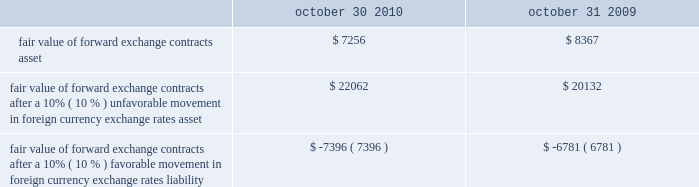The table illustrates the effect that a 10% ( 10 % ) unfavorable or favorable movement in foreign currency exchange rates , relative to the u.s .
Dollar , would have on the fair value of our forward exchange contracts as of october 30 , 2010 and october 31 , 2009: .
Fair value of forward exchange contracts after a 10% ( 10 % ) unfavorable movement in foreign currency exchange rates asset .
$ 22062 $ 20132 fair value of forward exchange contracts after a 10% ( 10 % ) favorable movement in foreign currency exchange rates liability .
$ ( 7396 ) $ ( 6781 ) the calculation assumes that each exchange rate would change in the same direction relative to the u.s .
Dollar .
In addition to the direct effects of changes in exchange rates , such changes typically affect the volume of sales or the foreign currency sales price as competitors 2019 products become more or less attractive .
Our sensitivity analysis of the effects of changes in foreign currency exchange rates does not factor in a potential change in sales levels or local currency selling prices. .
What is the growth rate in the fair value of forward exchange contracts after a 10% ( 10 % ) unfavorable movement in foreign currency exchange rates asset from 2009 to 2010? 
Computations: ((22062 - 20132) / 20132)
Answer: 0.09587. 